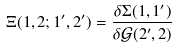Convert formula to latex. <formula><loc_0><loc_0><loc_500><loc_500>\Xi ( 1 , 2 ; 1 ^ { \prime } , 2 ^ { \prime } ) = \frac { \delta \Sigma ( 1 , 1 ^ { \prime } ) } { \delta { \mathcal { G } } ( 2 ^ { \prime } , 2 ) }</formula> 